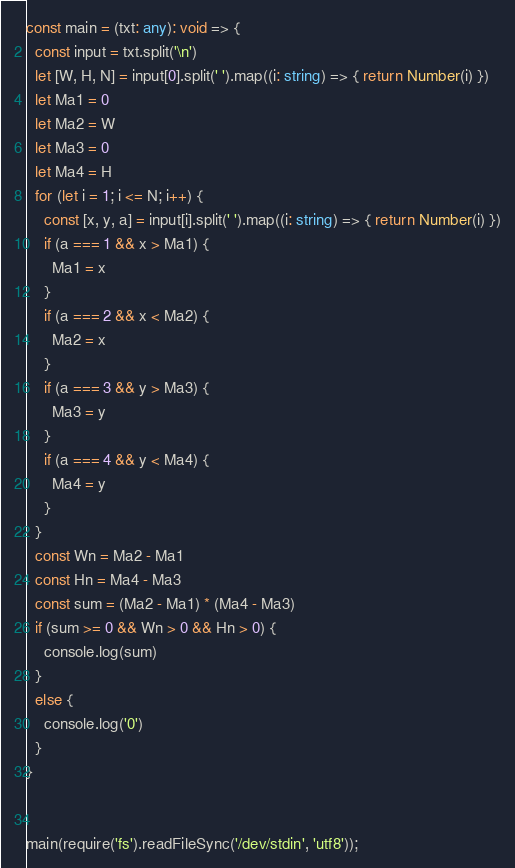<code> <loc_0><loc_0><loc_500><loc_500><_TypeScript_>const main = (txt: any): void => {
  const input = txt.split('\n')
  let [W, H, N] = input[0].split(' ').map((i: string) => { return Number(i) })
  let Ma1 = 0
  let Ma2 = W
  let Ma3 = 0
  let Ma4 = H
  for (let i = 1; i <= N; i++) {
    const [x, y, a] = input[i].split(' ').map((i: string) => { return Number(i) })
    if (a === 1 && x > Ma1) {
      Ma1 = x
    }
    if (a === 2 && x < Ma2) {
      Ma2 = x
    }
    if (a === 3 && y > Ma3) {
      Ma3 = y
    }
    if (a === 4 && y < Ma4) {
      Ma4 = y
    }
  }
  const Wn = Ma2 - Ma1
  const Hn = Ma4 - Ma3
  const sum = (Ma2 - Ma1) * (Ma4 - Ma3)
  if (sum >= 0 && Wn > 0 && Hn > 0) {
    console.log(sum)
  }
  else {
    console.log('0')
  }
}


main(require('fs').readFileSync('/dev/stdin', 'utf8'));</code> 